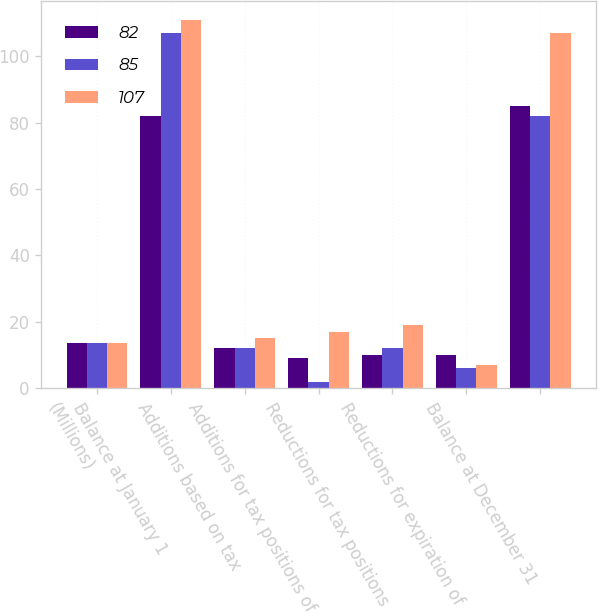Convert chart. <chart><loc_0><loc_0><loc_500><loc_500><stacked_bar_chart><ecel><fcel>(Millions)<fcel>Balance at January 1<fcel>Additions based on tax<fcel>Additions for tax positions of<fcel>Reductions for tax positions<fcel>Reductions for expiration of<fcel>Balance at December 31<nl><fcel>82<fcel>13.5<fcel>82<fcel>12<fcel>9<fcel>10<fcel>10<fcel>85<nl><fcel>85<fcel>13.5<fcel>107<fcel>12<fcel>2<fcel>12<fcel>6<fcel>82<nl><fcel>107<fcel>13.5<fcel>111<fcel>15<fcel>17<fcel>19<fcel>7<fcel>107<nl></chart> 